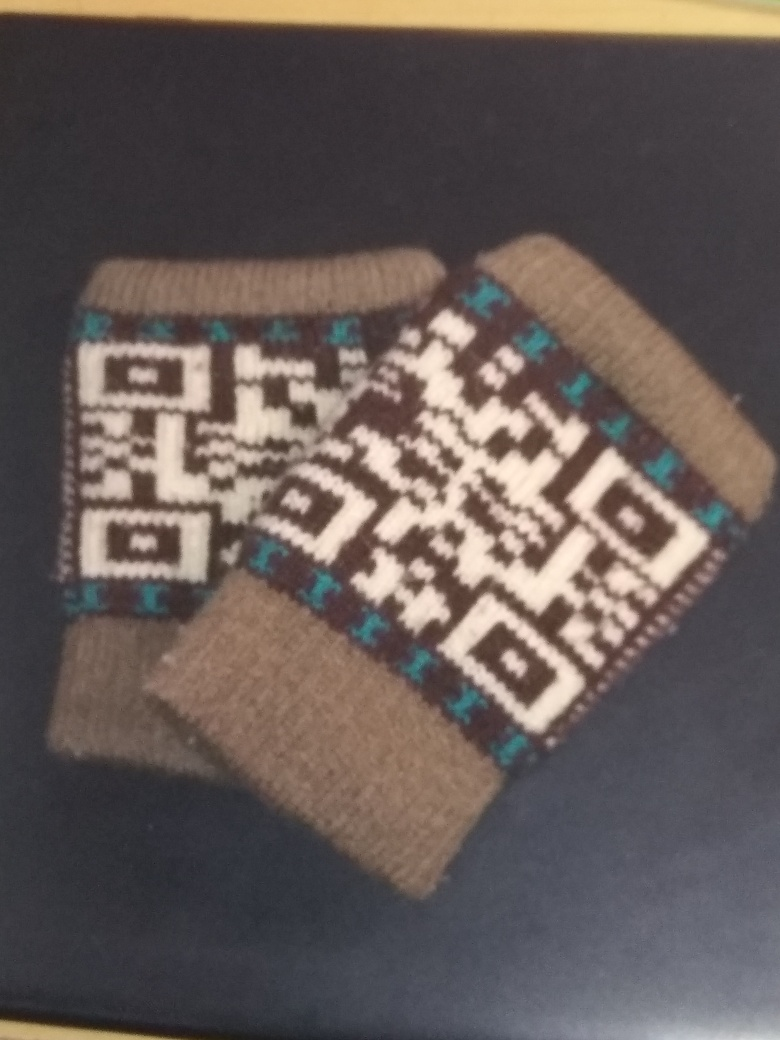Is the color monotonous in the image? While the image predominantly features earth tones, the presence of blue and white accents creates a contrast that breaks the monochromatic scheme of the piece. So, no, the coloration is not entirely monotonous. 